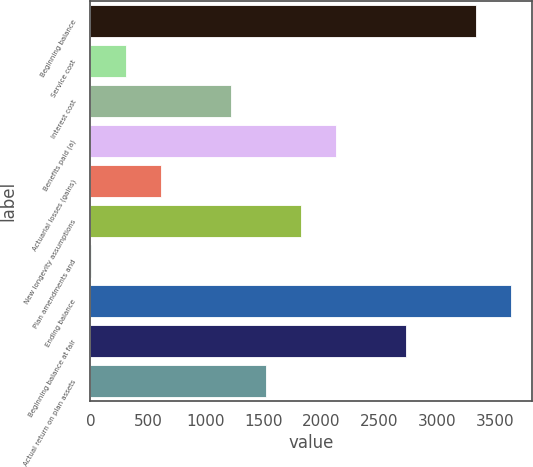<chart> <loc_0><loc_0><loc_500><loc_500><bar_chart><fcel>Beginning balance<fcel>Service cost<fcel>Interest cost<fcel>Benefits paid (a)<fcel>Actuarial losses (gains)<fcel>New longevity assumptions<fcel>Plan amendments and<fcel>Ending balance<fcel>Beginning balance at fair<fcel>Actual return on plan assets<nl><fcel>3336.9<fcel>307.9<fcel>1216.6<fcel>2125.3<fcel>610.8<fcel>1822.4<fcel>5<fcel>3639.8<fcel>2731.1<fcel>1519.5<nl></chart> 